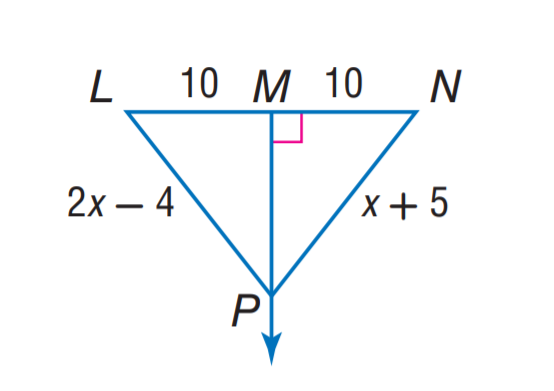Question: Find N P.
Choices:
A. 4
B. 7
C. 10
D. 14
Answer with the letter. Answer: D 